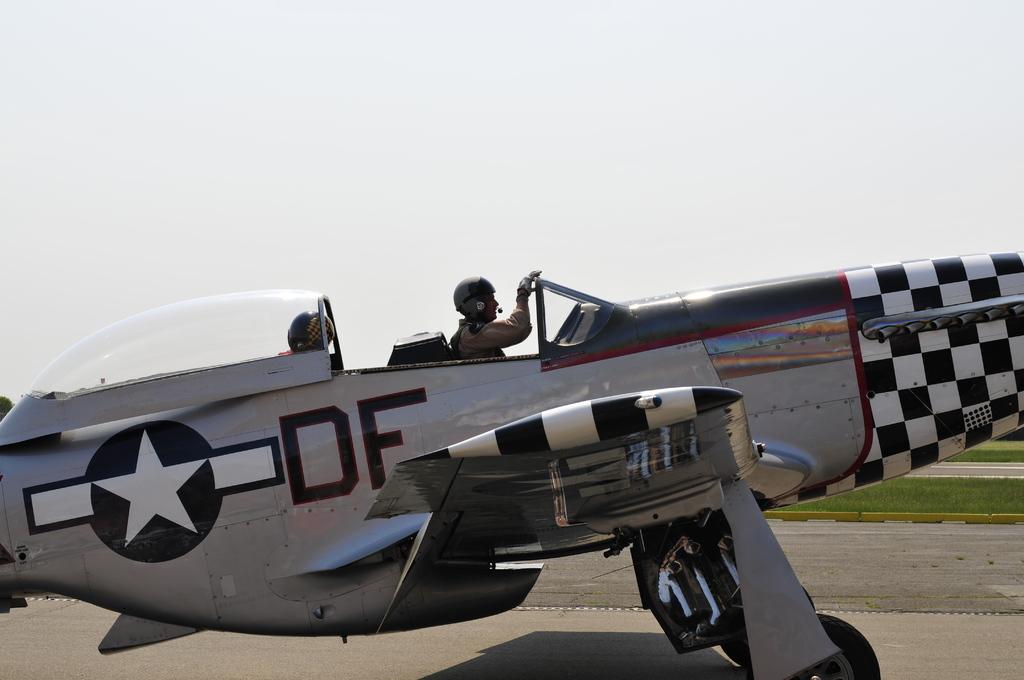What does it say on the plane?
Your answer should be very brief. Df. 